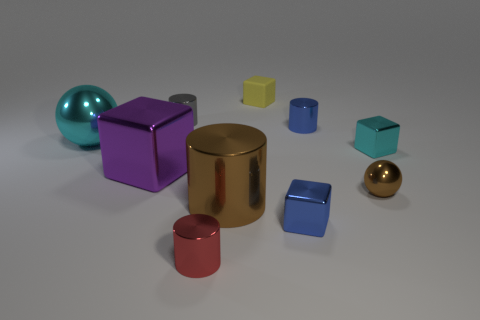Is the number of tiny yellow cubes in front of the red metal thing greater than the number of blue cubes on the left side of the purple shiny block?
Your answer should be very brief. No. There is a yellow thing that is the same size as the cyan metal block; what is its material?
Offer a very short reply. Rubber. What number of tiny things are cyan cylinders or red metallic things?
Make the answer very short. 1. Is the tiny cyan metallic thing the same shape as the gray metal thing?
Provide a succinct answer. No. What number of small cubes are behind the gray shiny cylinder and in front of the big cube?
Your answer should be very brief. 0. Is there any other thing that has the same color as the tiny metallic sphere?
Give a very brief answer. Yes. The red object that is the same material as the gray cylinder is what shape?
Give a very brief answer. Cylinder. Is the size of the blue shiny block the same as the brown metal cylinder?
Offer a terse response. No. Are the sphere to the right of the cyan metallic sphere and the blue block made of the same material?
Provide a succinct answer. Yes. Are there any other things that have the same material as the yellow thing?
Make the answer very short. No. 